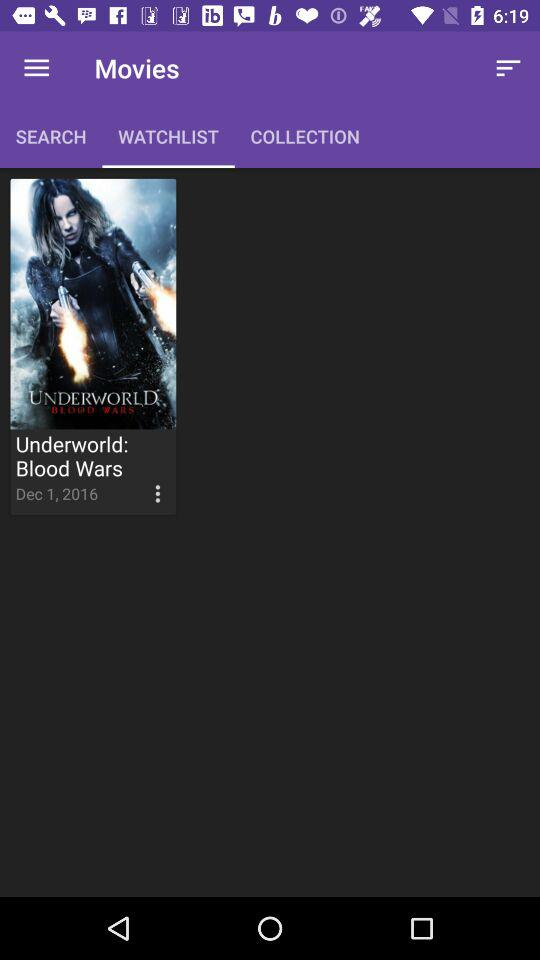On which date was the movie "Underworld: Blood Wars" released? The movie was released on December 1, 2016. 